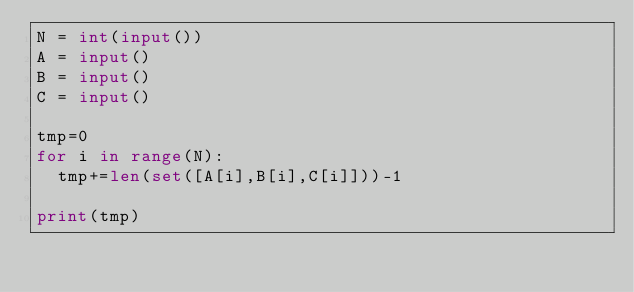<code> <loc_0><loc_0><loc_500><loc_500><_Python_>N = int(input())
A = input()
B = input()
C = input()

tmp=0
for i in range(N):
  tmp+=len(set([A[i],B[i],C[i]]))-1

print(tmp)</code> 